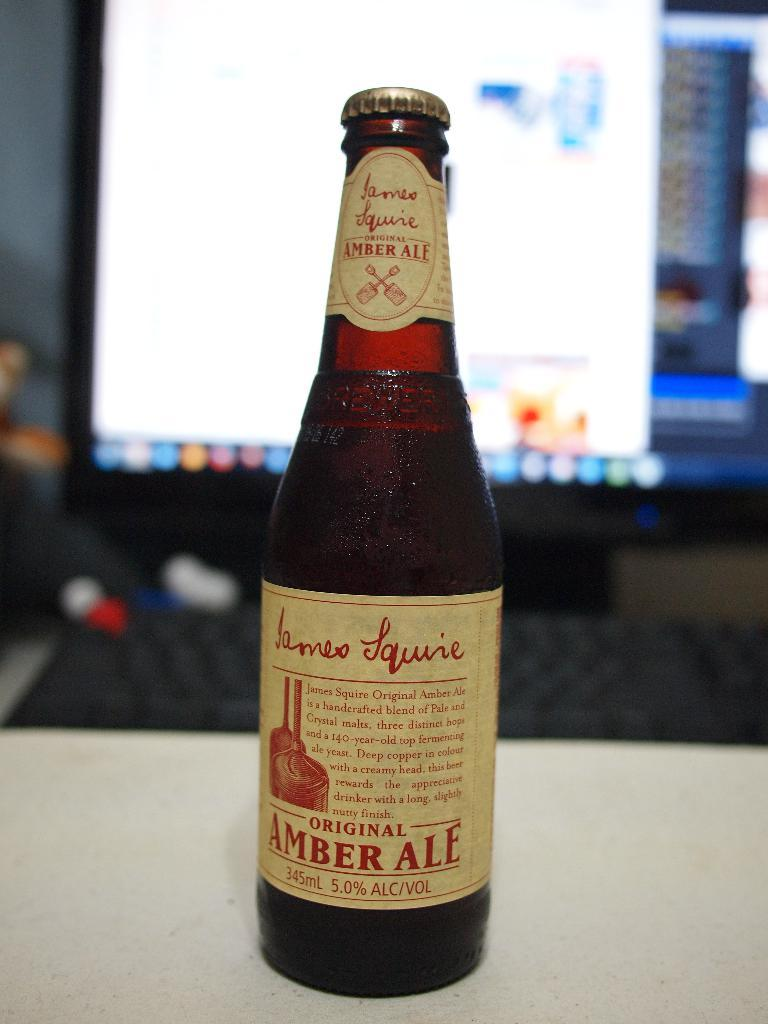<image>
Summarize the visual content of the image. A bottle of James Squire Amber Ale in front of a large screen. 